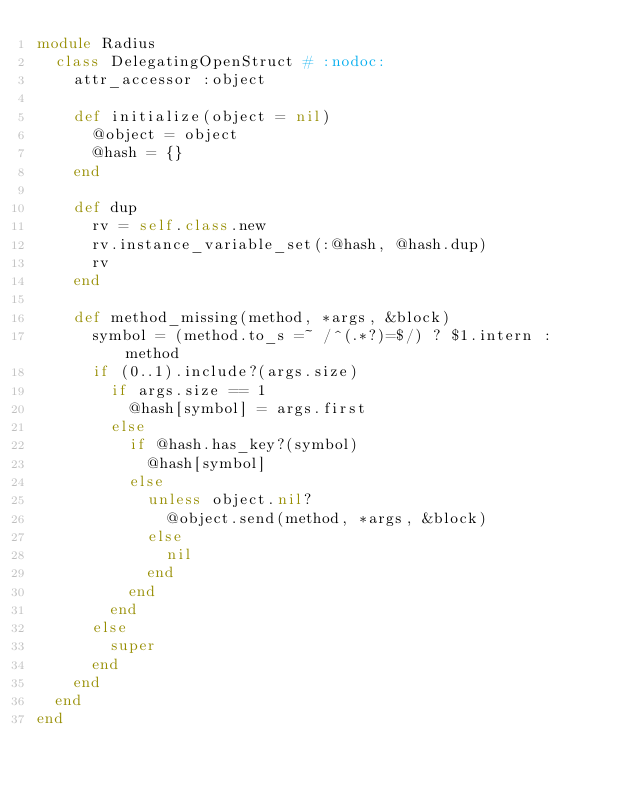Convert code to text. <code><loc_0><loc_0><loc_500><loc_500><_Ruby_>module Radius
  class DelegatingOpenStruct # :nodoc:
    attr_accessor :object
    
    def initialize(object = nil)
      @object = object
      @hash = {}
    end

    def dup
      rv = self.class.new
      rv.instance_variable_set(:@hash, @hash.dup)
      rv
    end
    
    def method_missing(method, *args, &block)
      symbol = (method.to_s =~ /^(.*?)=$/) ? $1.intern : method
      if (0..1).include?(args.size)
        if args.size == 1
          @hash[symbol] = args.first
        else
          if @hash.has_key?(symbol)
            @hash[symbol]
          else
            unless object.nil?
              @object.send(method, *args, &block)
            else
              nil
            end
          end
        end
      else
        super
      end
    end
  end
end
</code> 